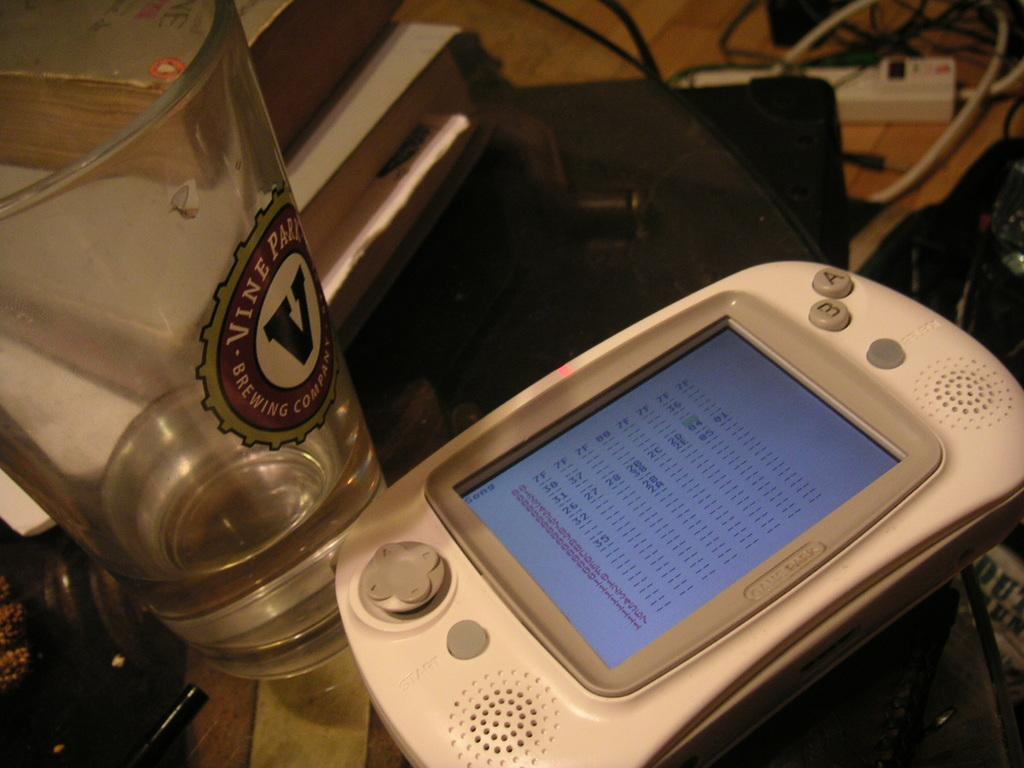<image>
Relay a brief, clear account of the picture shown. Small video game device that says Game Park on it. 